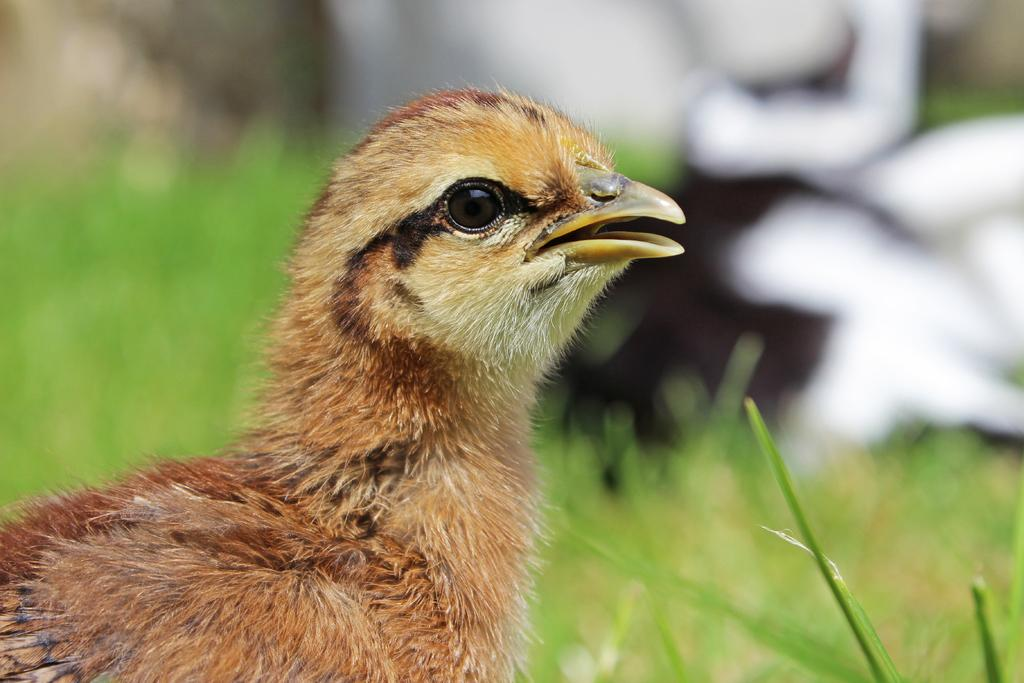What type of animal is in the picture? There is a baby chicken in the picture. Where is the baby chicken located in the image? The baby chicken is on the left side of the image. What type of vegetation is on the right side of the image? There is green grass on the right side of the image. What type of pies can be seen in the image? There are no pies present in the image; it features a baby chicken and green grass. 